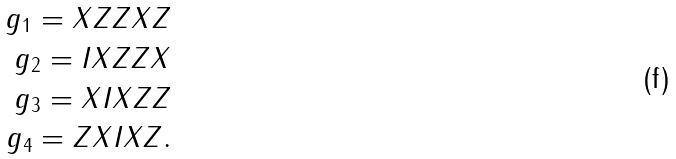Convert formula to latex. <formula><loc_0><loc_0><loc_500><loc_500>g _ { 1 } = X Z Z X Z \\ g _ { 2 } = I X Z Z X \\ g _ { 3 } = X I X Z Z \\ g _ { 4 } = Z X I X Z .</formula> 